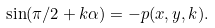<formula> <loc_0><loc_0><loc_500><loc_500>\sin ( \pi / 2 + k \alpha ) = - p ( x , y , k ) .</formula> 